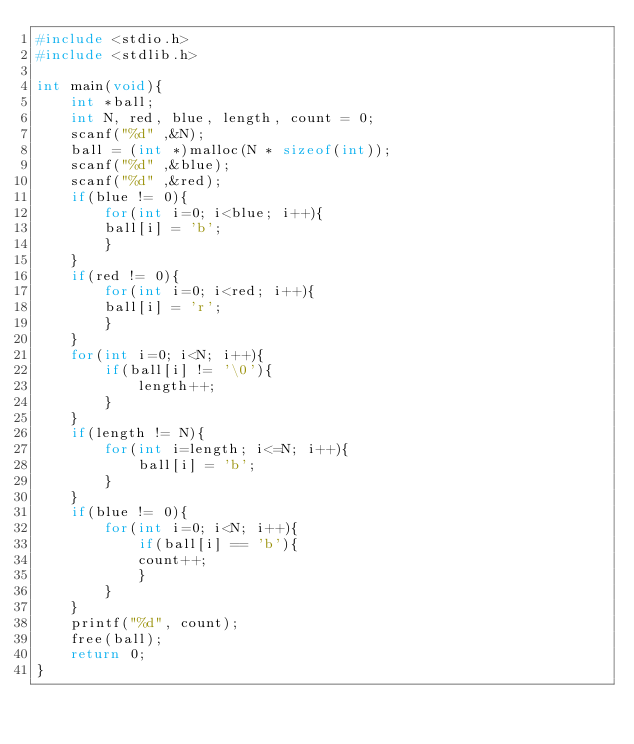Convert code to text. <code><loc_0><loc_0><loc_500><loc_500><_C_>#include <stdio.h>
#include <stdlib.h>

int main(void){
    int *ball;
    int N, red, blue, length, count = 0;
    scanf("%d" ,&N);
    ball = (int *)malloc(N * sizeof(int));
    scanf("%d" ,&blue);
    scanf("%d" ,&red);
    if(blue != 0){
        for(int i=0; i<blue; i++){
        ball[i] = 'b';
        }
    }
    if(red != 0){
        for(int i=0; i<red; i++){
        ball[i] = 'r';
        } 
    }
    for(int i=0; i<N; i++){
        if(ball[i] != '\0'){
            length++;
        }
    }
    if(length != N){
        for(int i=length; i<=N; i++){
            ball[i] = 'b';
        }
    }
    if(blue != 0){
        for(int i=0; i<N; i++){
            if(ball[i] == 'b'){
            count++;
            }
        } 
    }
    printf("%d", count);
    free(ball);
    return 0;
}</code> 